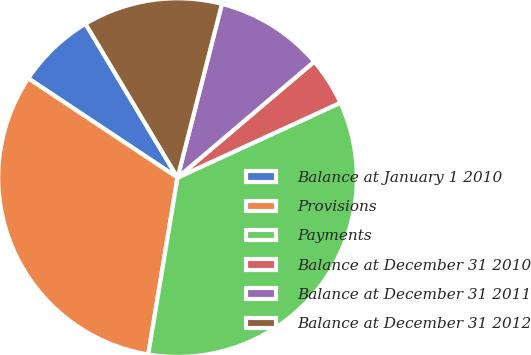<chart> <loc_0><loc_0><loc_500><loc_500><pie_chart><fcel>Balance at January 1 2010<fcel>Provisions<fcel>Payments<fcel>Balance at December 31 2010<fcel>Balance at December 31 2011<fcel>Balance at December 31 2012<nl><fcel>7.08%<fcel>31.72%<fcel>34.47%<fcel>4.34%<fcel>9.82%<fcel>12.56%<nl></chart> 